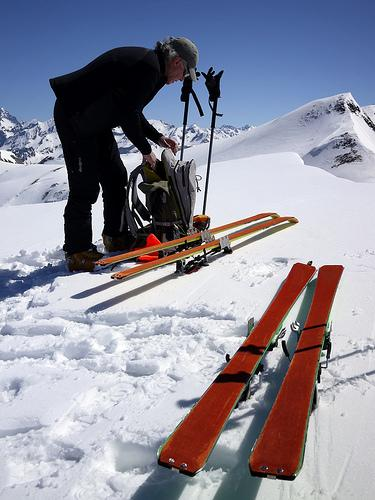Describe the location and what can be seen in the background. The image is set in a snowy area with snow-covered mountains in the background and footprints and tracks in the snow. List the colors of the objects the man is wearing and holding. The man is wearing and holding objects in colors like black, grey, and red. Briefly mention the man's hairstyle and an accessory he is wearing on his head. The man has gray hair and is wearing a grey baseball hat. What is the color of the skis in the image? There are two sets of red skis in the image. Write a sentence about an object the man is holding and what it is used for. The man is holding two black ski poles with gloves on the handles, used for skiing assistance and balance. Can you describe a feature of the man's face in the image? The man has sunglasses on his face. What type of hat is the man wearing, and what is its color? The man is wearing a grey or light grey baseball hat. Provide a brief description of the overall scene in the image. The image shows a man dressed in winter clothing, holding ski poles, and standing amidst snow, with tracks and footprints, red skis, and snowy mountains in the background. What is the man's backpack's color, and what is he doing with it? The man is wearing a gray or grey backpack, and he is looking inside it. What does the ground appear to be covered with, and what evidence of activity is visible? The ground is covered with snow, and there are footprints and ski tracks made in the snow. 